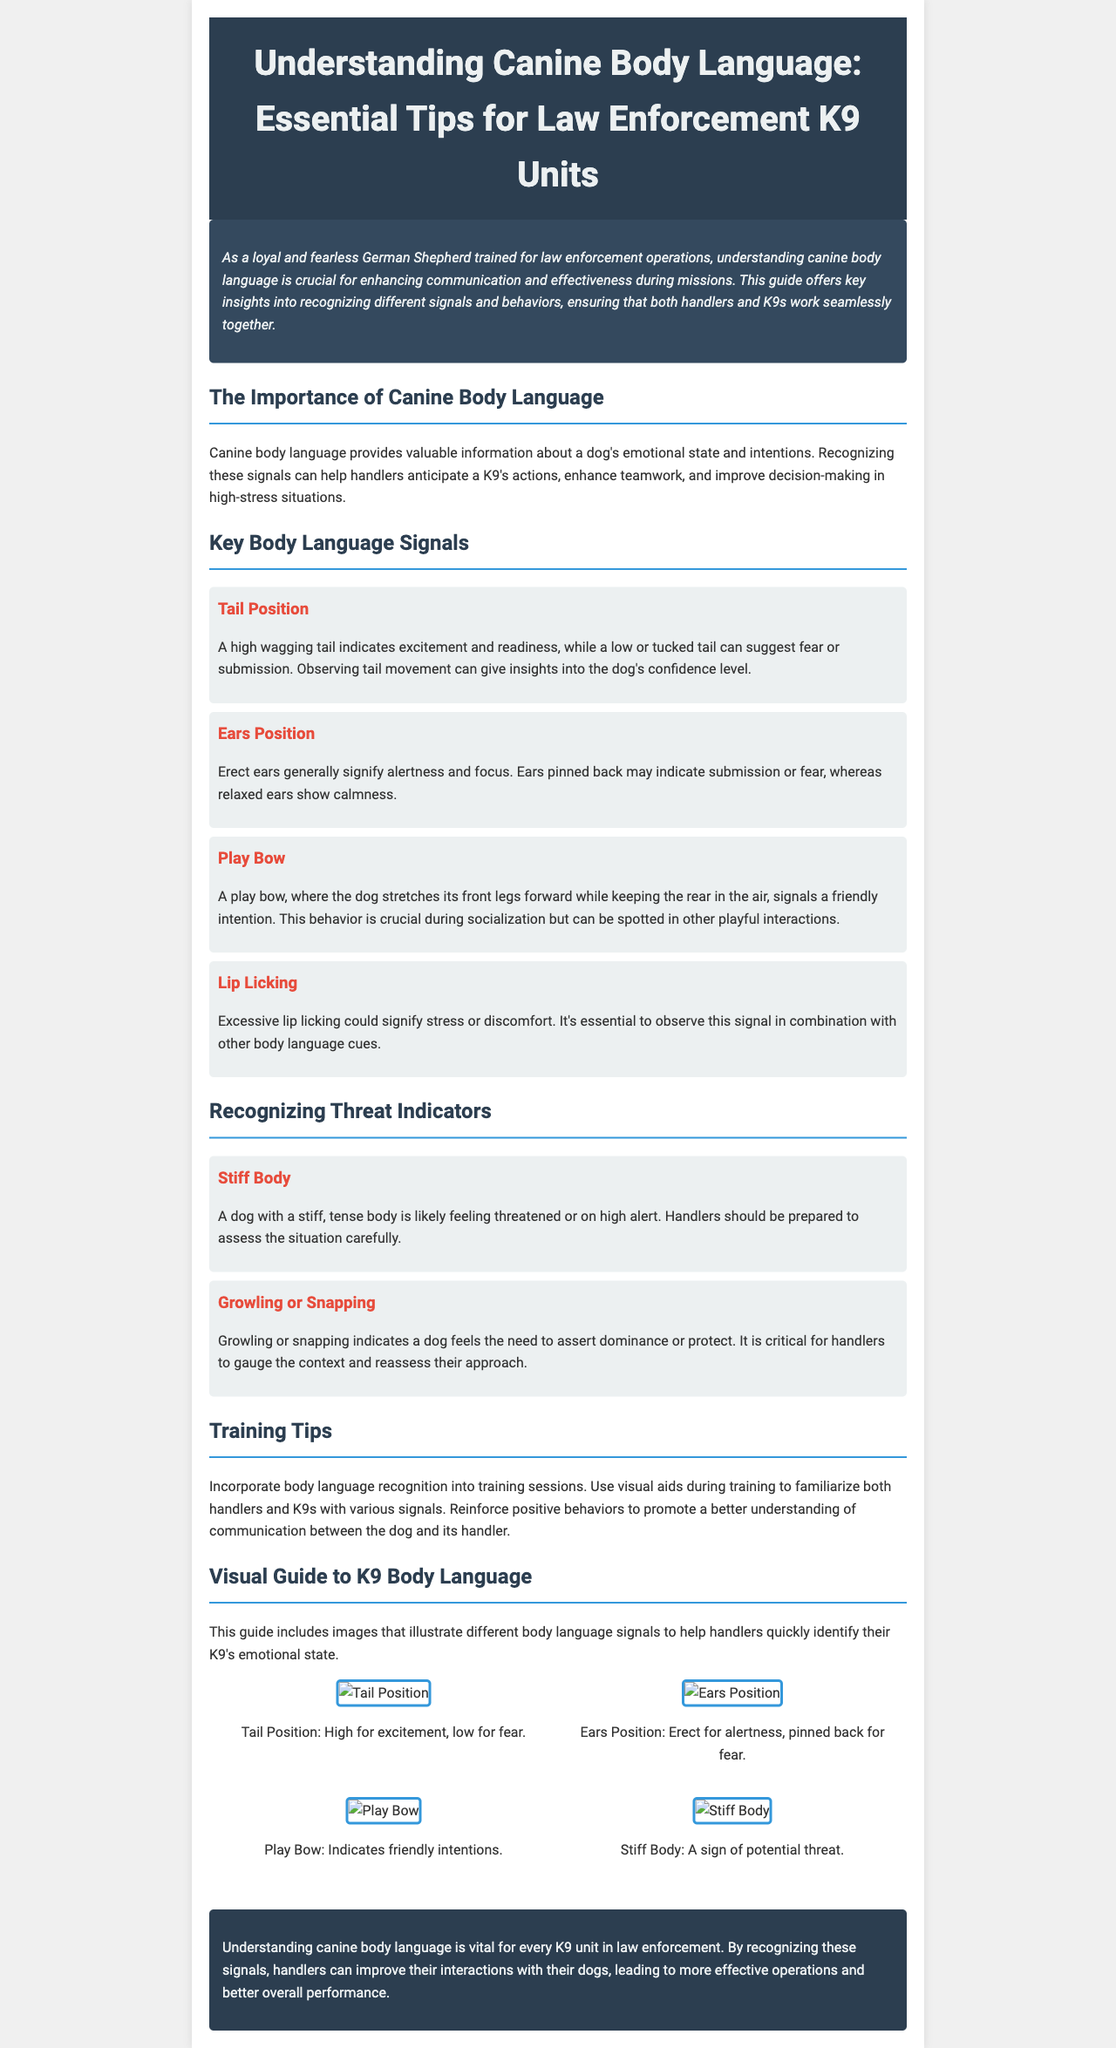What is the title of the newsletter? The title of the newsletter is located at the top of the document and provides the central theme of the content focused on K9s.
Answer: Understanding Canine Body Language: Essential Tips for Law Enforcement K9 Units What does a high wagging tail indicate? A high wagging tail signal described in the document represents specific emotional states of the dog and its eagerness.
Answer: Excitement What body position suggests a dog is feeling threatened? This behavioral signal indicates a physical change in the dog's body shape and posture, suggesting stress in the animal.
Answer: Stiff Body How should handlers respond to lip licking? This behavior signifies emotional discomfort, and handlers are advised to consider it alongside other signals to understand the dog's feelings.
Answer: Observe with caution What are the three positions of the ears mentioned? The ears' position is crucial to understanding canine emotions, and the document lists specific meanings for each position.
Answer: Erect, Pinned Back, Relaxed What is the importance of canine body language as highlighted in the document? The document emphasizes how this understanding contributes to operational effectiveness and communication between K9s and their handlers during law enforcement activities.
Answer: Enhances communication How should training incorporate body language recognition? Training is suggested to actively include this recognition as a component to foster better understanding between the dog and handler.
Answer: Use visual aids What does the 'Play Bow' behavior indicate? The interaction described informs handlers about friendly behavior, aiding in softening tense dynamics during socialization or play.
Answer: Friendly intention 